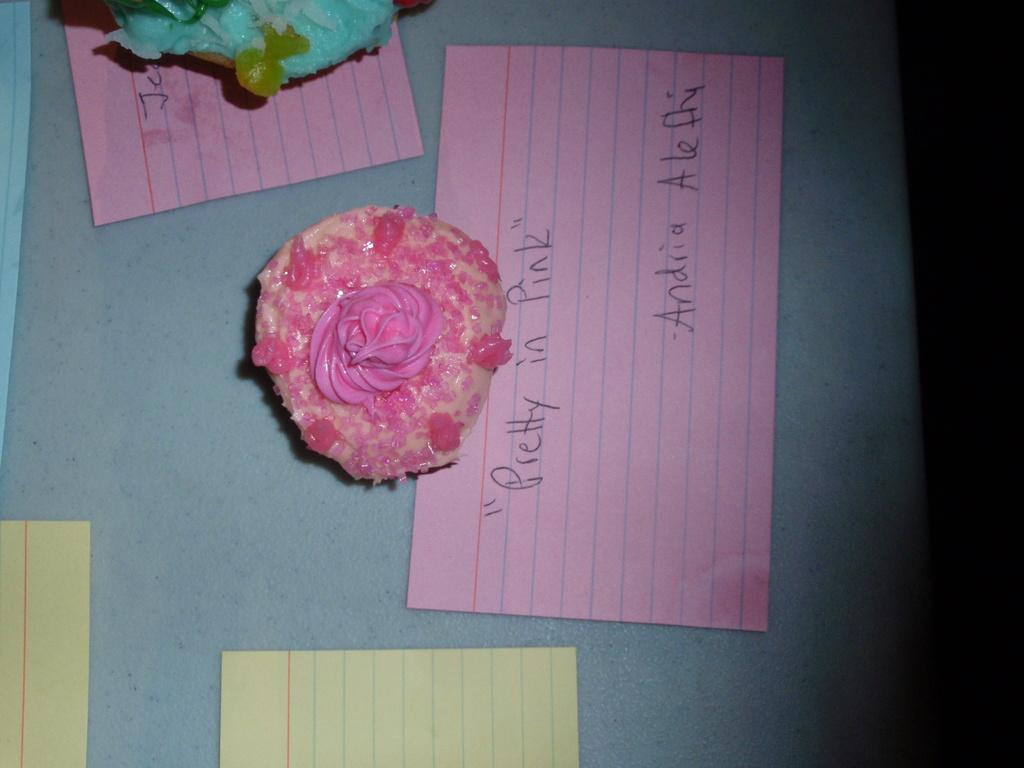What is the color of the cream on the cake in the image? The cream on the cake in the image is pink. What is located below the cake in the image? There is a paper with something written on it below the cake. How many other papers are visible in the image? There are multiple other papers visible in the image. Where is the second cake located in the image? The second cake is on the top left side of the image. What type of fruit is the pear that your brother is holding as a slave in the image? There is no pear, brother, or slave present in the image. 